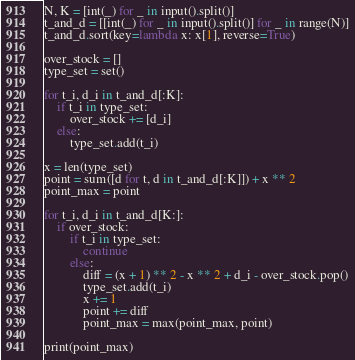<code> <loc_0><loc_0><loc_500><loc_500><_Python_>N, K = [int(_) for _ in input().split()]
t_and_d = [[int(_) for _ in input().split()] for _ in range(N)]
t_and_d.sort(key=lambda x: x[1], reverse=True)

over_stock = []
type_set = set()

for t_i, d_i in t_and_d[:K]:
    if t_i in type_set:
        over_stock += [d_i]
    else:
        type_set.add(t_i)

x = len(type_set)
point = sum([d for t, d in t_and_d[:K]]) + x ** 2
point_max = point

for t_i, d_i in t_and_d[K:]:
    if over_stock:
        if t_i in type_set:
            continue
        else:
            diff = (x + 1) ** 2 - x ** 2 + d_i - over_stock.pop()
            type_set.add(t_i)
            x += 1
            point += diff
            point_max = max(point_max, point)

print(point_max)</code> 